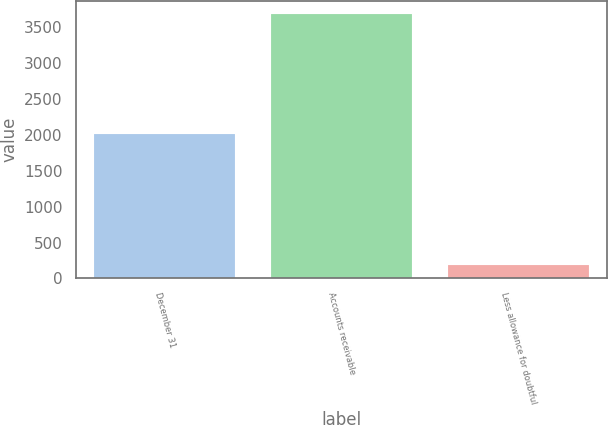<chart> <loc_0><loc_0><loc_500><loc_500><bar_chart><fcel>December 31<fcel>Accounts receivable<fcel>Less allowance for doubtful<nl><fcel>2008<fcel>3675<fcel>182<nl></chart> 